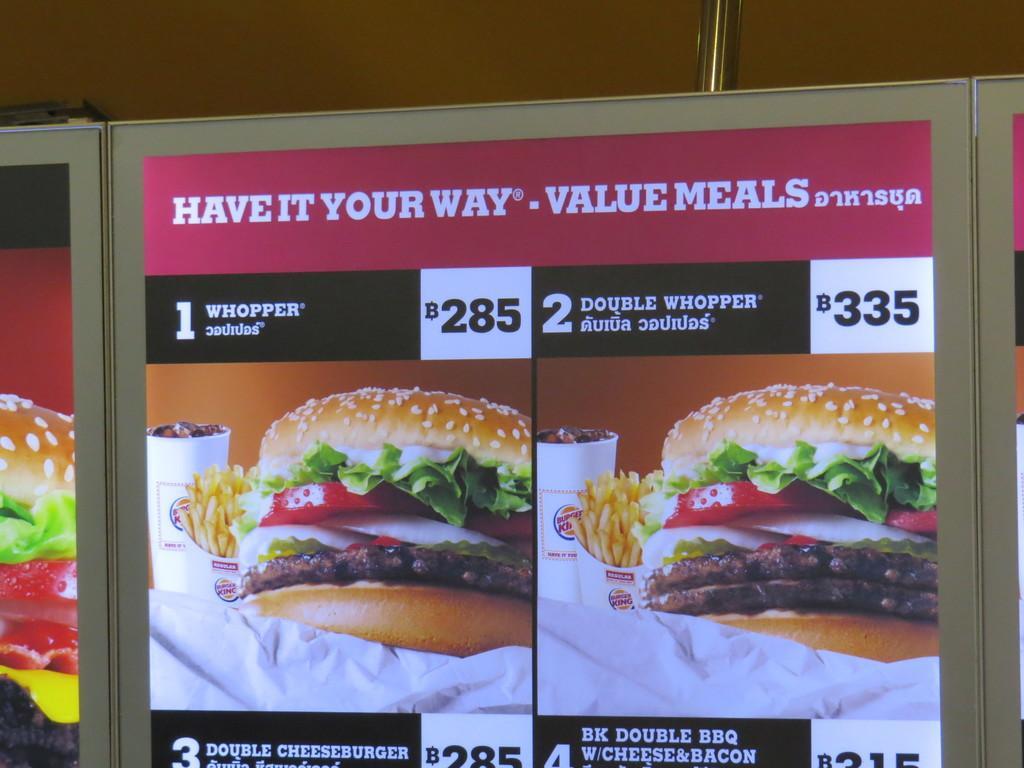Can you describe this image briefly? In the picture we can see a board on it, we can see an advertisement of a burger with a price to it. 